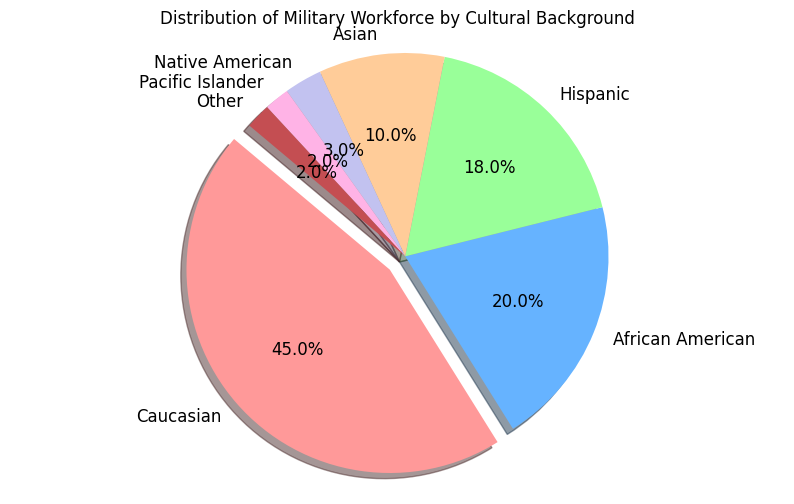What is the approximate percentage of the military workforce composed of Native American and Pacific Islander backgrounds combined? Native American accounts for 3% and Pacific Islander for 2%. Adding these percentages together: 3% + 2% = 5%
Answer: 5% Which cultural background has the highest representation in the military workforce? By visually inspecting the pie chart, the section labeled 'Caucasian' appears to be the largest section, indicating it has the highest percentage.
Answer: Caucasian How much greater is the percentage of the Hispanic workforce compared to the Asian workforce? The percentage for the Hispanic workforce is 18% and for the Asian workforce is 10%. Subtract the Asian percentage from the Hispanic percentage: 18% - 10% = 8%
Answer: 8% What is the average percentage of the workforce from African American, Hispanic, and Asian backgrounds? Sum the percentages: 20% (African American) + 18% (Hispanic) + 10% (Asian) = 48%. Then, divide by the number of groups: 48% / 3 = 16%
Answer: 16% Of the smaller represented groups (Native American, Pacific Islander, Other), which one has the smallest segment in the pie chart? By visually comparing the sizes of the segments, the 'Other' group appears to be the smallest.
Answer: Other How does the representation of the African American workforce compare to the Caucasian workforce visually? The African American segment is smaller than the Caucasian segment. Specifically, the percentage for African American is 20%, whereas for Caucasian, it is 45%.
Answer: African American is smaller What is the total percentage of all cultural backgrounds not including Caucasian? Add up the percentages of all groups except Caucasian: 20% (African American) + 18% (Hispanic) + 10% (Asian) + 3% (Native American) + 2% (Pacific Islander) + 2% (Other) = 55%
Answer: 55% Which color represents the Asian workforce in the pie chart? The section representing the Asian workforce is the fourth from the top moving counterclockwise, appearing in a greenish hue.
Answer: Green If the segments representing Native American and Pacific Islander backgrounds were combined, how would they compare in size to the segment representing Asian background? Combining Native American (3%) and Pacific Islander (2%) gives a total of 5%, which is still smaller than the Asian segment at 10%.
Answer: Smaller 